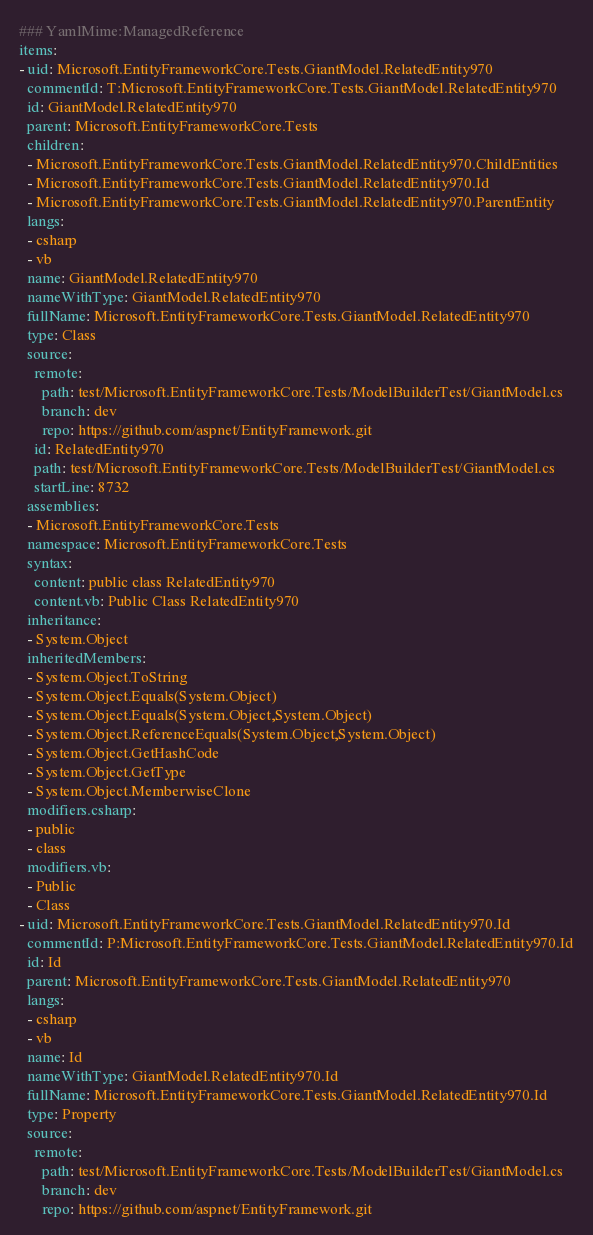Convert code to text. <code><loc_0><loc_0><loc_500><loc_500><_YAML_>### YamlMime:ManagedReference
items:
- uid: Microsoft.EntityFrameworkCore.Tests.GiantModel.RelatedEntity970
  commentId: T:Microsoft.EntityFrameworkCore.Tests.GiantModel.RelatedEntity970
  id: GiantModel.RelatedEntity970
  parent: Microsoft.EntityFrameworkCore.Tests
  children:
  - Microsoft.EntityFrameworkCore.Tests.GiantModel.RelatedEntity970.ChildEntities
  - Microsoft.EntityFrameworkCore.Tests.GiantModel.RelatedEntity970.Id
  - Microsoft.EntityFrameworkCore.Tests.GiantModel.RelatedEntity970.ParentEntity
  langs:
  - csharp
  - vb
  name: GiantModel.RelatedEntity970
  nameWithType: GiantModel.RelatedEntity970
  fullName: Microsoft.EntityFrameworkCore.Tests.GiantModel.RelatedEntity970
  type: Class
  source:
    remote:
      path: test/Microsoft.EntityFrameworkCore.Tests/ModelBuilderTest/GiantModel.cs
      branch: dev
      repo: https://github.com/aspnet/EntityFramework.git
    id: RelatedEntity970
    path: test/Microsoft.EntityFrameworkCore.Tests/ModelBuilderTest/GiantModel.cs
    startLine: 8732
  assemblies:
  - Microsoft.EntityFrameworkCore.Tests
  namespace: Microsoft.EntityFrameworkCore.Tests
  syntax:
    content: public class RelatedEntity970
    content.vb: Public Class RelatedEntity970
  inheritance:
  - System.Object
  inheritedMembers:
  - System.Object.ToString
  - System.Object.Equals(System.Object)
  - System.Object.Equals(System.Object,System.Object)
  - System.Object.ReferenceEquals(System.Object,System.Object)
  - System.Object.GetHashCode
  - System.Object.GetType
  - System.Object.MemberwiseClone
  modifiers.csharp:
  - public
  - class
  modifiers.vb:
  - Public
  - Class
- uid: Microsoft.EntityFrameworkCore.Tests.GiantModel.RelatedEntity970.Id
  commentId: P:Microsoft.EntityFrameworkCore.Tests.GiantModel.RelatedEntity970.Id
  id: Id
  parent: Microsoft.EntityFrameworkCore.Tests.GiantModel.RelatedEntity970
  langs:
  - csharp
  - vb
  name: Id
  nameWithType: GiantModel.RelatedEntity970.Id
  fullName: Microsoft.EntityFrameworkCore.Tests.GiantModel.RelatedEntity970.Id
  type: Property
  source:
    remote:
      path: test/Microsoft.EntityFrameworkCore.Tests/ModelBuilderTest/GiantModel.cs
      branch: dev
      repo: https://github.com/aspnet/EntityFramework.git</code> 